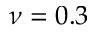<formula> <loc_0><loc_0><loc_500><loc_500>\nu = 0 . 3</formula> 